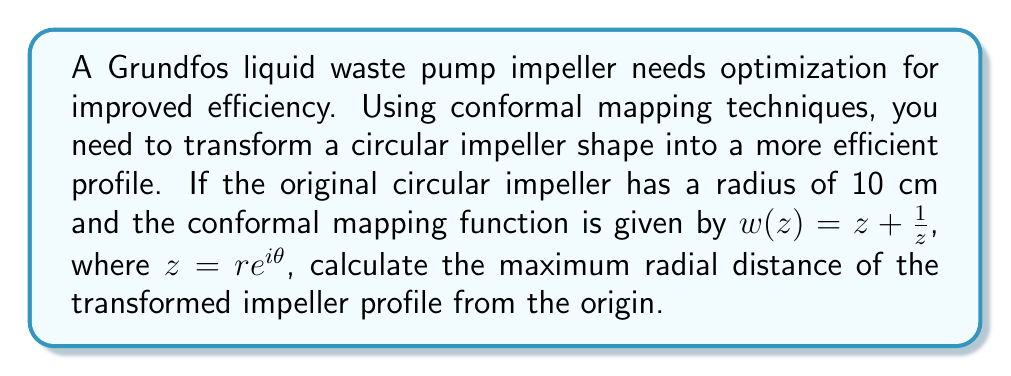Can you solve this math problem? Let's approach this step-by-step:

1) The conformal mapping function is given by:
   $$w(z) = z + \frac{1}{z}$$

2) We're given that $z = re^{i\theta}$, where $r = 10$ cm (the original radius).

3) Substituting this into the mapping function:
   $$w(re^{i\theta}) = re^{i\theta} + \frac{1}{re^{i\theta}}$$

4) Using Euler's formula, $e^{i\theta} = \cos\theta + i\sin\theta$, we can rewrite this as:
   $$w(r,\theta) = r(\cos\theta + i\sin\theta) + \frac{1}{r}(\cos\theta - i\sin\theta)$$

5) Separating real and imaginary parts:
   $$\text{Re}(w) = r\cos\theta + \frac{1}{r}\cos\theta$$
   $$\text{Im}(w) = r\sin\theta - \frac{1}{r}\sin\theta$$

6) The radial distance from the origin in the w-plane is given by:
   $$|w| = \sqrt{(\text{Re}(w))^2 + (\text{Im}(w))^2}$$

7) Substituting and simplifying:
   $$|w| = \sqrt{(r\cos\theta + \frac{1}{r}\cos\theta)^2 + (r\sin\theta - \frac{1}{r}\sin\theta)^2}$$
   $$|w| = \sqrt{r^2 + \frac{1}{r^2} + 2\cos(2\theta)}$$

8) To find the maximum radial distance, we need to maximize this expression. The maximum occurs when $\cos(2\theta) = 1$, i.e., when $\theta = 0$ or $\pi$.

9) Substituting $r = 10$ and $\cos(2\theta) = 1$:
   $$|w|_\text{max} = \sqrt{10^2 + \frac{1}{10^2} + 2} = \sqrt{100.01} \approx 10.0005\text{ cm}$$

Therefore, the maximum radial distance of the transformed impeller profile from the origin is approximately 10.0005 cm.
Answer: 10.0005 cm 